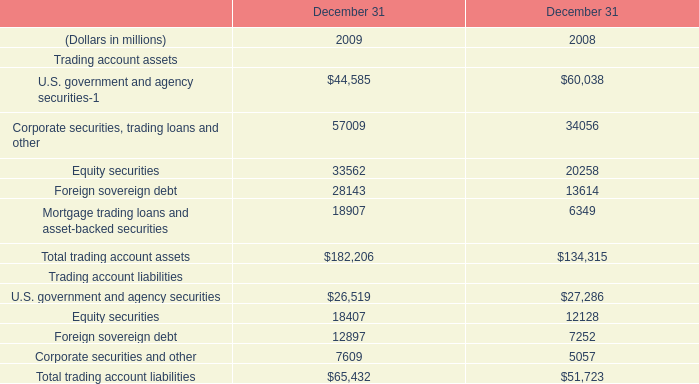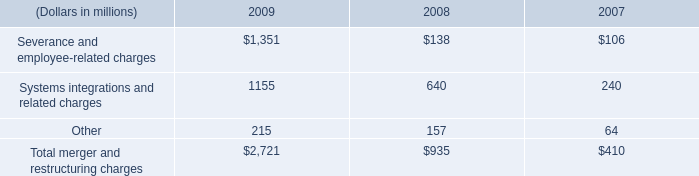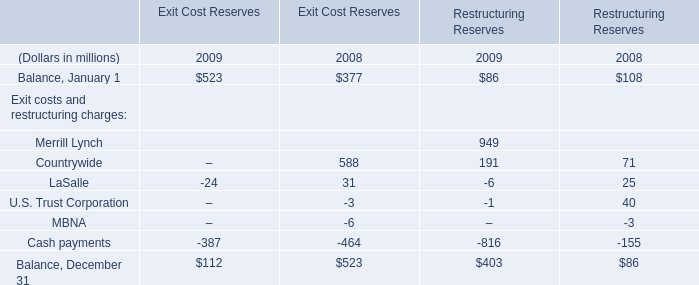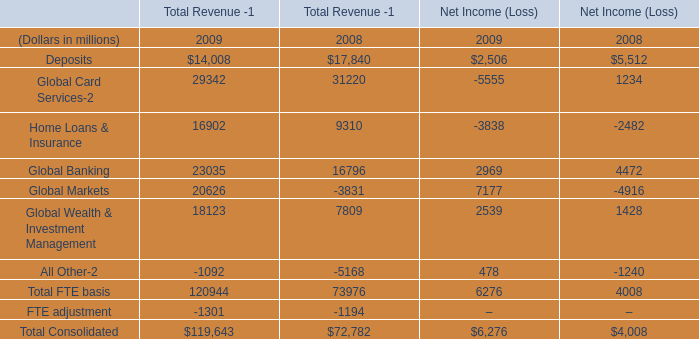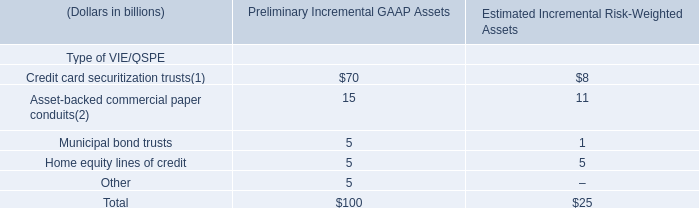What's the total amount of Exit costs and restructuring charges excluding those negative ones in 2009? (in million) 
Computations: (949 + 191)
Answer: 1140.0. 